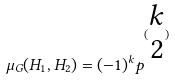<formula> <loc_0><loc_0><loc_500><loc_500>\mu _ { G } ( H _ { 1 } , H _ { 2 } ) = ( - 1 ) ^ { k } p ^ { ( \begin{matrix} k \\ 2 \end{matrix} ) }</formula> 